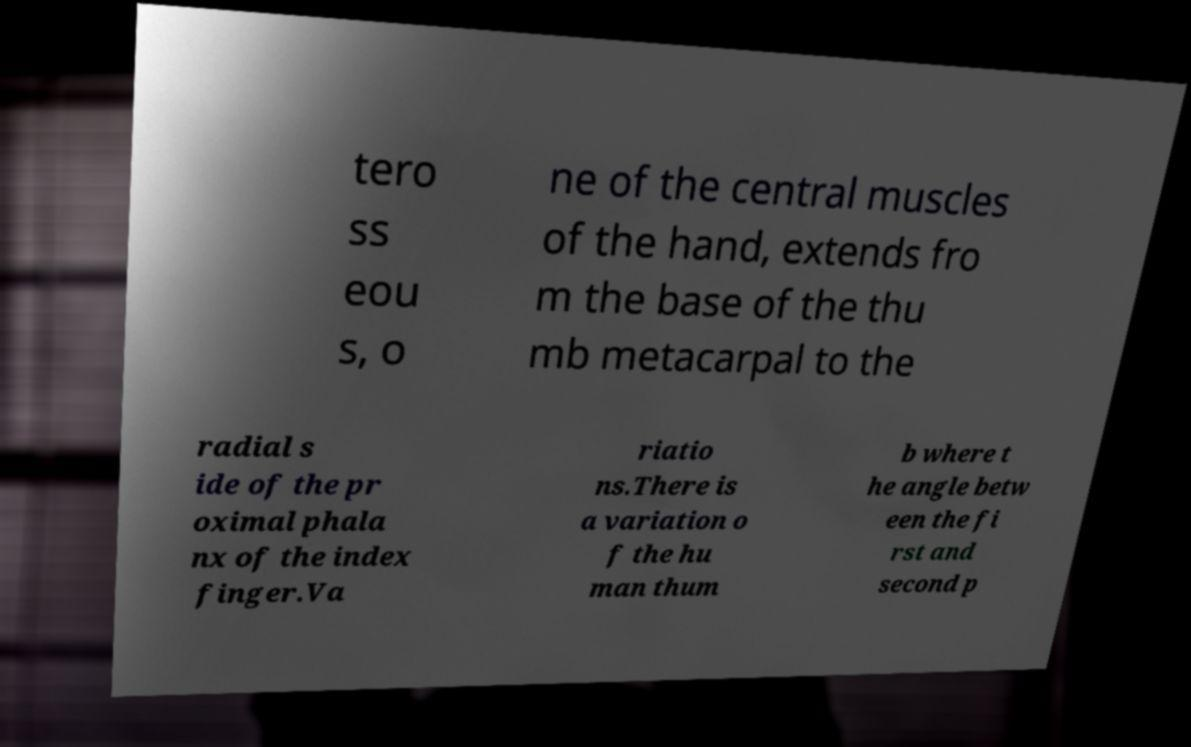Could you assist in decoding the text presented in this image and type it out clearly? tero ss eou s, o ne of the central muscles of the hand, extends fro m the base of the thu mb metacarpal to the radial s ide of the pr oximal phala nx of the index finger.Va riatio ns.There is a variation o f the hu man thum b where t he angle betw een the fi rst and second p 